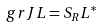<formula> <loc_0><loc_0><loc_500><loc_500>\ g r J L = S _ { R } L ^ { \ast }</formula> 